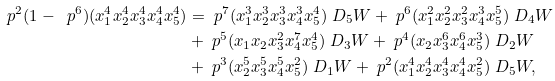<formula> <loc_0><loc_0><loc_500><loc_500>\ p ^ { 2 } ( 1 - \ p ^ { 6 } ) ( x _ { 1 } ^ { 4 } x _ { 2 } ^ { 4 } x _ { 3 } ^ { 4 } x _ { 4 } ^ { 4 } x _ { 5 } ^ { 4 } ) & = \ p ^ { 7 } ( x _ { 1 } ^ { 3 } x _ { 2 } ^ { 3 } x _ { 3 } ^ { 3 } x _ { 4 } ^ { 3 } x _ { 5 } ^ { 4 } ) \ D _ { 5 } W + \ p ^ { 6 } ( x _ { 1 } ^ { 2 } x _ { 2 } ^ { 2 } x _ { 3 } ^ { 2 } x _ { 4 } ^ { 3 } x _ { 5 } ^ { 5 } ) \ D _ { 4 } W \\ & + \ p ^ { 5 } ( x _ { 1 } x _ { 2 } x _ { 3 } ^ { 2 } x _ { 4 } ^ { 7 } x _ { 5 } ^ { 4 } ) \ D _ { 3 } W + \ p ^ { 4 } ( x _ { 2 } x _ { 3 } ^ { 6 } x _ { 4 } ^ { 6 } x _ { 5 } ^ { 3 } ) \ D _ { 2 } W \\ & + \ p ^ { 3 } ( x _ { 2 } ^ { 5 } x _ { 3 } ^ { 5 } x _ { 4 } ^ { 5 } x _ { 5 } ^ { 2 } ) \ D _ { 1 } W + \ p ^ { 2 } ( x _ { 1 } ^ { 4 } x _ { 2 } ^ { 4 } x _ { 3 } ^ { 4 } x _ { 4 } ^ { 4 } x _ { 5 } ^ { 2 } ) \ D _ { 5 } W ,</formula> 